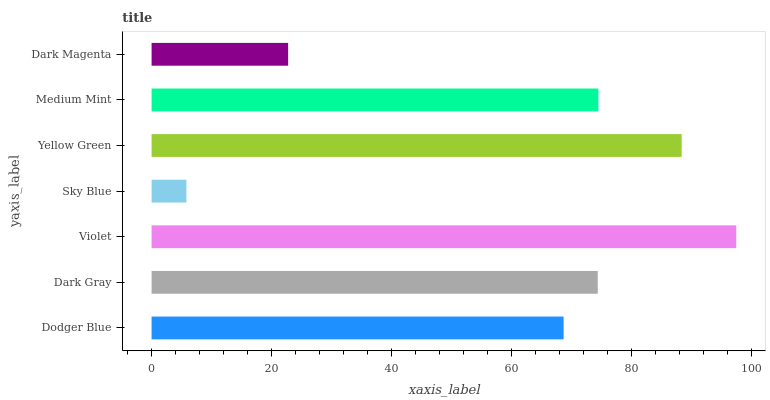Is Sky Blue the minimum?
Answer yes or no. Yes. Is Violet the maximum?
Answer yes or no. Yes. Is Dark Gray the minimum?
Answer yes or no. No. Is Dark Gray the maximum?
Answer yes or no. No. Is Dark Gray greater than Dodger Blue?
Answer yes or no. Yes. Is Dodger Blue less than Dark Gray?
Answer yes or no. Yes. Is Dodger Blue greater than Dark Gray?
Answer yes or no. No. Is Dark Gray less than Dodger Blue?
Answer yes or no. No. Is Dark Gray the high median?
Answer yes or no. Yes. Is Dark Gray the low median?
Answer yes or no. Yes. Is Dark Magenta the high median?
Answer yes or no. No. Is Violet the low median?
Answer yes or no. No. 